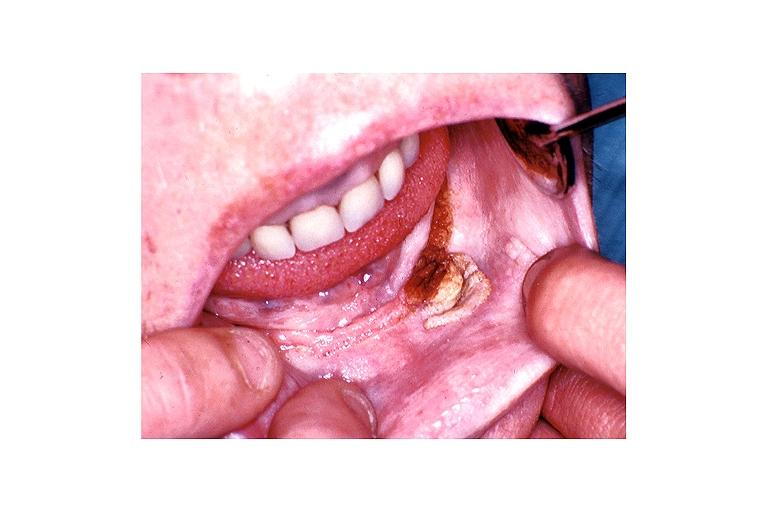s sugar coated present?
Answer the question using a single word or phrase. No 